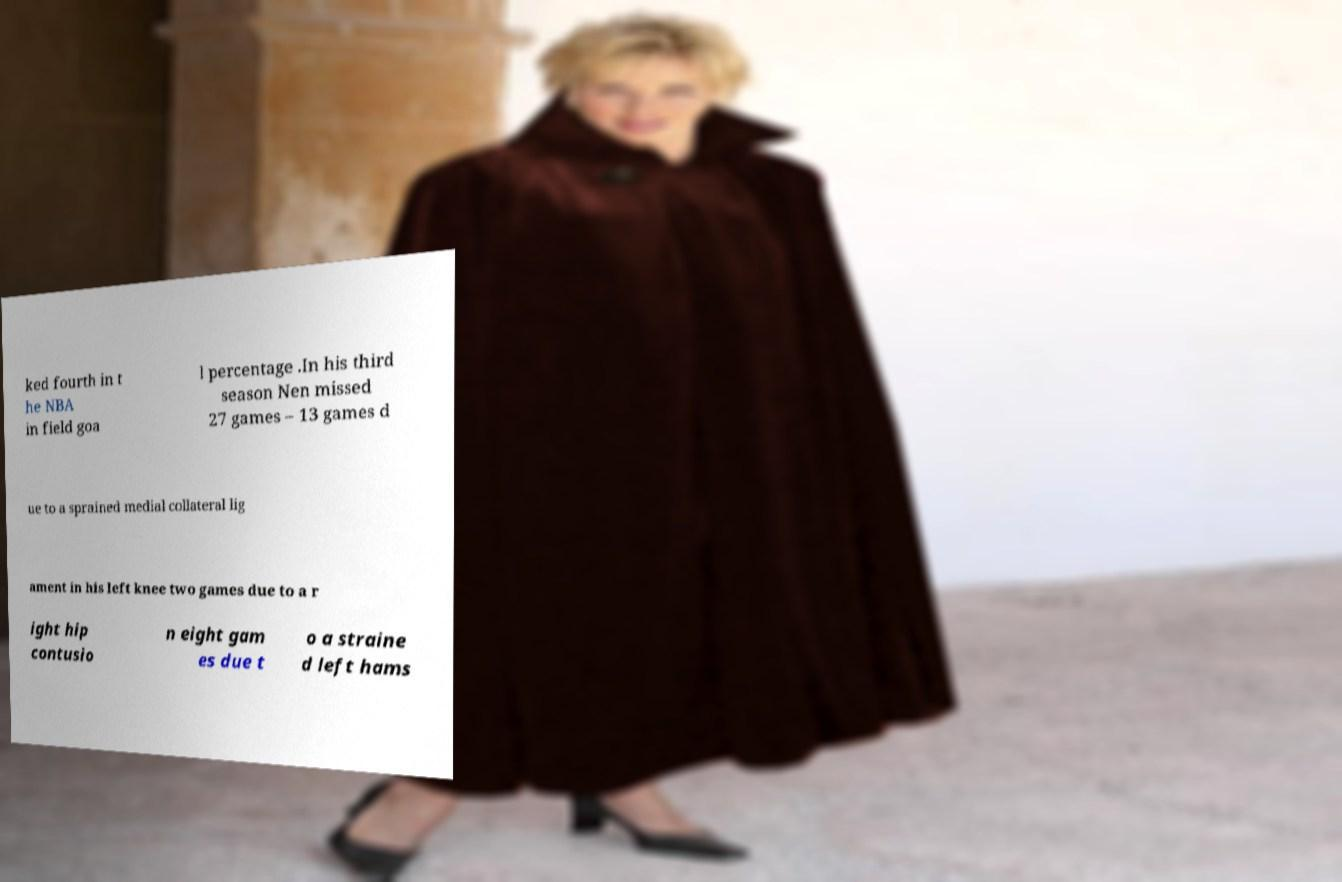Could you assist in decoding the text presented in this image and type it out clearly? ked fourth in t he NBA in field goa l percentage .In his third season Nen missed 27 games – 13 games d ue to a sprained medial collateral lig ament in his left knee two games due to a r ight hip contusio n eight gam es due t o a straine d left hams 